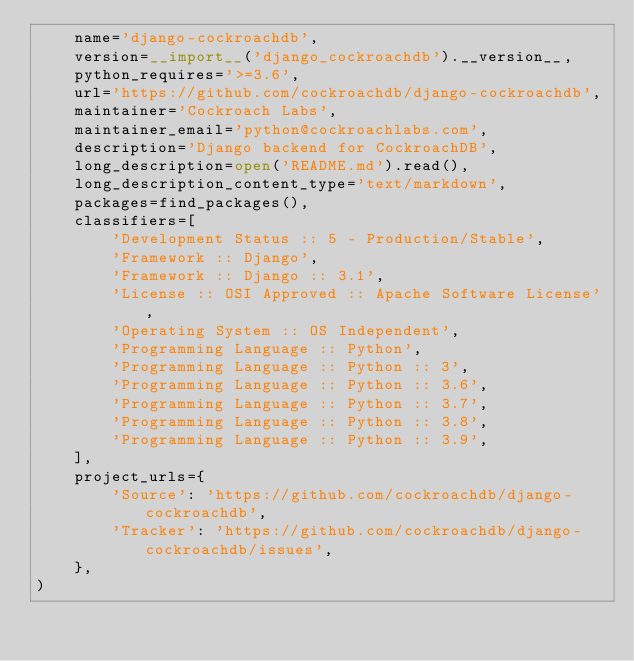Convert code to text. <code><loc_0><loc_0><loc_500><loc_500><_Python_>    name='django-cockroachdb',
    version=__import__('django_cockroachdb').__version__,
    python_requires='>=3.6',
    url='https://github.com/cockroachdb/django-cockroachdb',
    maintainer='Cockroach Labs',
    maintainer_email='python@cockroachlabs.com',
    description='Django backend for CockroachDB',
    long_description=open('README.md').read(),
    long_description_content_type='text/markdown',
    packages=find_packages(),
    classifiers=[
        'Development Status :: 5 - Production/Stable',
        'Framework :: Django',
        'Framework :: Django :: 3.1',
        'License :: OSI Approved :: Apache Software License',
        'Operating System :: OS Independent',
        'Programming Language :: Python',
        'Programming Language :: Python :: 3',
        'Programming Language :: Python :: 3.6',
        'Programming Language :: Python :: 3.7',
        'Programming Language :: Python :: 3.8',
        'Programming Language :: Python :: 3.9',
    ],
    project_urls={
        'Source': 'https://github.com/cockroachdb/django-cockroachdb',
        'Tracker': 'https://github.com/cockroachdb/django-cockroachdb/issues',
    },
)
</code> 